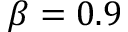Convert formula to latex. <formula><loc_0><loc_0><loc_500><loc_500>\beta = 0 . 9</formula> 